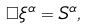Convert formula to latex. <formula><loc_0><loc_0><loc_500><loc_500>\Box \xi ^ { \alpha } = S ^ { \alpha } ,</formula> 